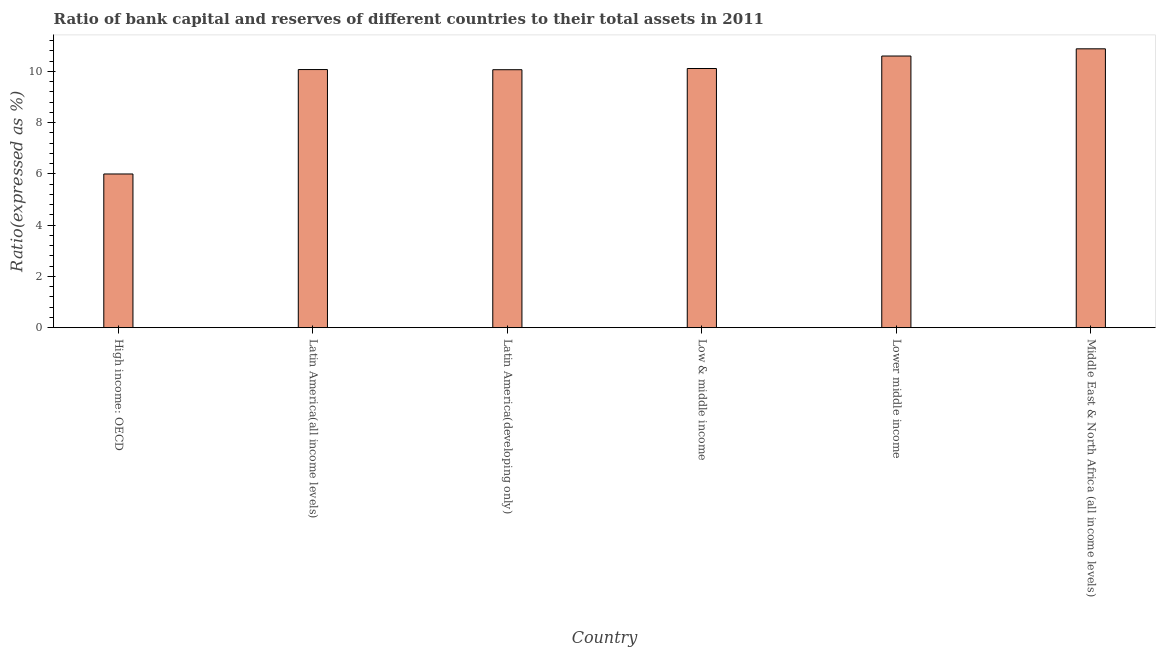Does the graph contain grids?
Your response must be concise. No. What is the title of the graph?
Offer a terse response. Ratio of bank capital and reserves of different countries to their total assets in 2011. What is the label or title of the Y-axis?
Your answer should be very brief. Ratio(expressed as %). What is the bank capital to assets ratio in Latin America(all income levels)?
Make the answer very short. 10.07. Across all countries, what is the maximum bank capital to assets ratio?
Give a very brief answer. 10.88. Across all countries, what is the minimum bank capital to assets ratio?
Make the answer very short. 6. In which country was the bank capital to assets ratio maximum?
Your response must be concise. Middle East & North Africa (all income levels). In which country was the bank capital to assets ratio minimum?
Offer a terse response. High income: OECD. What is the sum of the bank capital to assets ratio?
Provide a succinct answer. 57.73. What is the difference between the bank capital to assets ratio in Latin America(all income levels) and Middle East & North Africa (all income levels)?
Your response must be concise. -0.81. What is the average bank capital to assets ratio per country?
Your response must be concise. 9.62. What is the median bank capital to assets ratio?
Make the answer very short. 10.09. What is the ratio of the bank capital to assets ratio in High income: OECD to that in Lower middle income?
Provide a succinct answer. 0.57. Is the difference between the bank capital to assets ratio in High income: OECD and Middle East & North Africa (all income levels) greater than the difference between any two countries?
Your answer should be very brief. Yes. What is the difference between the highest and the second highest bank capital to assets ratio?
Your answer should be compact. 0.28. Is the sum of the bank capital to assets ratio in Lower middle income and Middle East & North Africa (all income levels) greater than the maximum bank capital to assets ratio across all countries?
Your answer should be very brief. Yes. What is the difference between the highest and the lowest bank capital to assets ratio?
Offer a terse response. 4.88. In how many countries, is the bank capital to assets ratio greater than the average bank capital to assets ratio taken over all countries?
Your answer should be compact. 5. How many countries are there in the graph?
Your response must be concise. 6. What is the difference between two consecutive major ticks on the Y-axis?
Offer a terse response. 2. Are the values on the major ticks of Y-axis written in scientific E-notation?
Your response must be concise. No. What is the Ratio(expressed as %) of High income: OECD?
Offer a terse response. 6. What is the Ratio(expressed as %) of Latin America(all income levels)?
Offer a very short reply. 10.07. What is the Ratio(expressed as %) of Latin America(developing only)?
Make the answer very short. 10.07. What is the Ratio(expressed as %) in Low & middle income?
Your answer should be very brief. 10.11. What is the Ratio(expressed as %) in Middle East & North Africa (all income levels)?
Your response must be concise. 10.88. What is the difference between the Ratio(expressed as %) in High income: OECD and Latin America(all income levels)?
Offer a very short reply. -4.08. What is the difference between the Ratio(expressed as %) in High income: OECD and Latin America(developing only)?
Provide a succinct answer. -4.07. What is the difference between the Ratio(expressed as %) in High income: OECD and Low & middle income?
Provide a succinct answer. -4.12. What is the difference between the Ratio(expressed as %) in High income: OECD and Lower middle income?
Provide a short and direct response. -4.6. What is the difference between the Ratio(expressed as %) in High income: OECD and Middle East & North Africa (all income levels)?
Keep it short and to the point. -4.88. What is the difference between the Ratio(expressed as %) in Latin America(all income levels) and Latin America(developing only)?
Provide a short and direct response. 0.01. What is the difference between the Ratio(expressed as %) in Latin America(all income levels) and Low & middle income?
Your answer should be very brief. -0.04. What is the difference between the Ratio(expressed as %) in Latin America(all income levels) and Lower middle income?
Ensure brevity in your answer.  -0.53. What is the difference between the Ratio(expressed as %) in Latin America(all income levels) and Middle East & North Africa (all income levels)?
Offer a very short reply. -0.81. What is the difference between the Ratio(expressed as %) in Latin America(developing only) and Low & middle income?
Offer a terse response. -0.05. What is the difference between the Ratio(expressed as %) in Latin America(developing only) and Lower middle income?
Your answer should be compact. -0.53. What is the difference between the Ratio(expressed as %) in Latin America(developing only) and Middle East & North Africa (all income levels)?
Make the answer very short. -0.82. What is the difference between the Ratio(expressed as %) in Low & middle income and Lower middle income?
Your answer should be compact. -0.49. What is the difference between the Ratio(expressed as %) in Low & middle income and Middle East & North Africa (all income levels)?
Offer a terse response. -0.77. What is the difference between the Ratio(expressed as %) in Lower middle income and Middle East & North Africa (all income levels)?
Provide a short and direct response. -0.28. What is the ratio of the Ratio(expressed as %) in High income: OECD to that in Latin America(all income levels)?
Make the answer very short. 0.59. What is the ratio of the Ratio(expressed as %) in High income: OECD to that in Latin America(developing only)?
Keep it short and to the point. 0.6. What is the ratio of the Ratio(expressed as %) in High income: OECD to that in Low & middle income?
Provide a succinct answer. 0.59. What is the ratio of the Ratio(expressed as %) in High income: OECD to that in Lower middle income?
Your response must be concise. 0.57. What is the ratio of the Ratio(expressed as %) in High income: OECD to that in Middle East & North Africa (all income levels)?
Ensure brevity in your answer.  0.55. What is the ratio of the Ratio(expressed as %) in Latin America(all income levels) to that in Latin America(developing only)?
Your answer should be very brief. 1. What is the ratio of the Ratio(expressed as %) in Latin America(all income levels) to that in Middle East & North Africa (all income levels)?
Ensure brevity in your answer.  0.93. What is the ratio of the Ratio(expressed as %) in Latin America(developing only) to that in Middle East & North Africa (all income levels)?
Keep it short and to the point. 0.93. What is the ratio of the Ratio(expressed as %) in Low & middle income to that in Lower middle income?
Your answer should be very brief. 0.95. What is the ratio of the Ratio(expressed as %) in Low & middle income to that in Middle East & North Africa (all income levels)?
Give a very brief answer. 0.93. What is the ratio of the Ratio(expressed as %) in Lower middle income to that in Middle East & North Africa (all income levels)?
Provide a succinct answer. 0.97. 